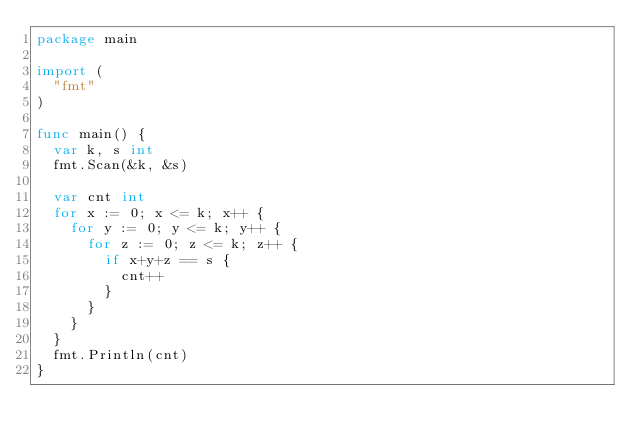Convert code to text. <code><loc_0><loc_0><loc_500><loc_500><_Go_>package main

import (
	"fmt"
)

func main() {
	var k, s int
	fmt.Scan(&k, &s)

	var cnt int
	for x := 0; x <= k; x++ {
		for y := 0; y <= k; y++ {
			for z := 0; z <= k; z++ {
				if x+y+z == s {
					cnt++
				}
			}
		}
	}
	fmt.Println(cnt)
}
</code> 